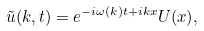Convert formula to latex. <formula><loc_0><loc_0><loc_500><loc_500>\tilde { u } ( k , t ) = e ^ { - i \omega ( k ) t + i k x } U ( x ) ,</formula> 